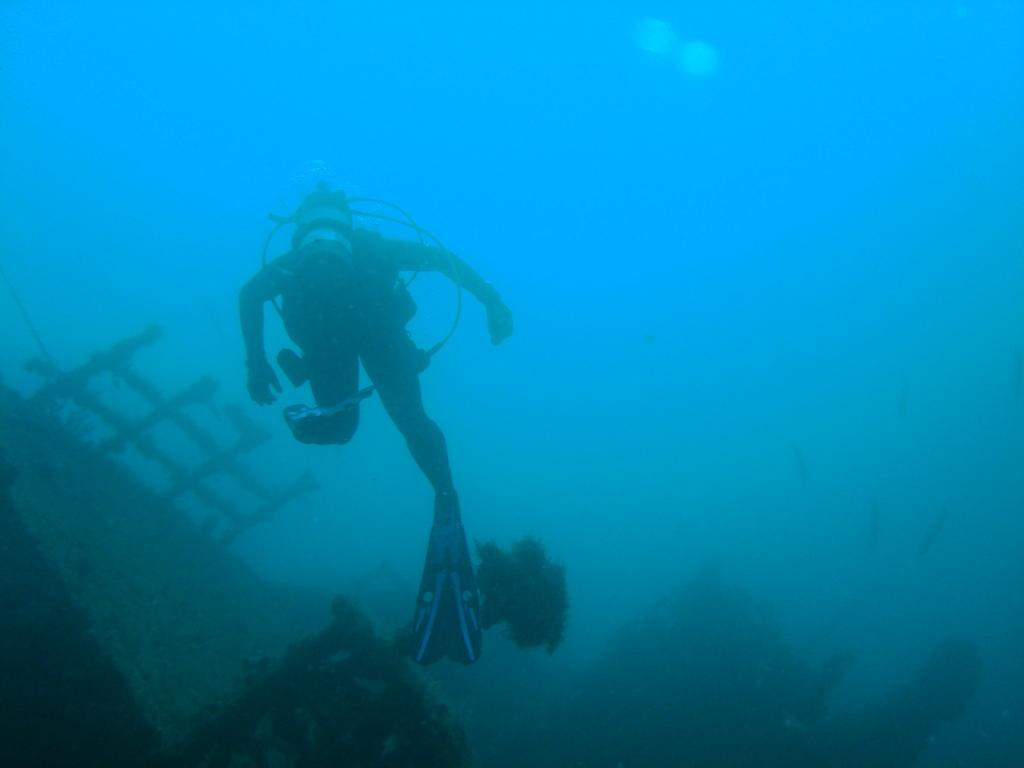What is the person in the image doing? There is a person in the water in the image. What other objects can be seen in the image? There are poles and a plant in the image. What type of zinc is present in the image? There is no zinc present in the image. How many ducks can be seen swimming in the water with the person? There are no ducks visible in the image; it only shows a person in the water and other objects. 